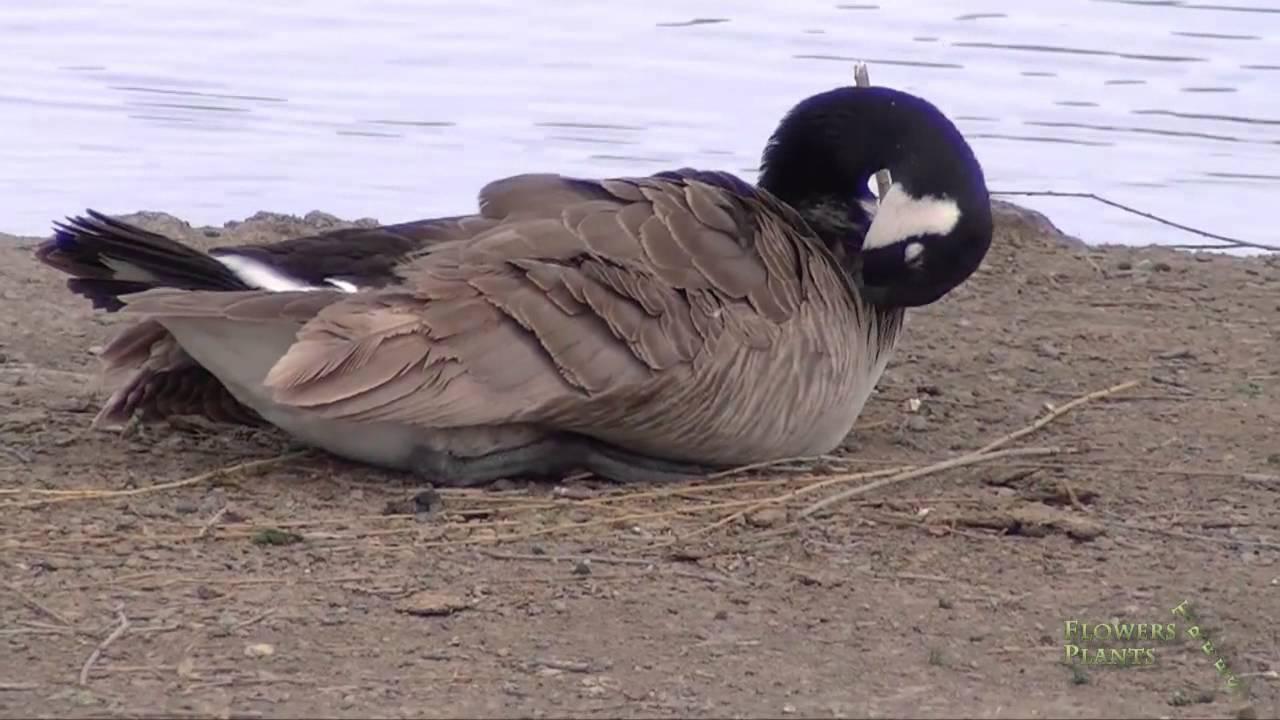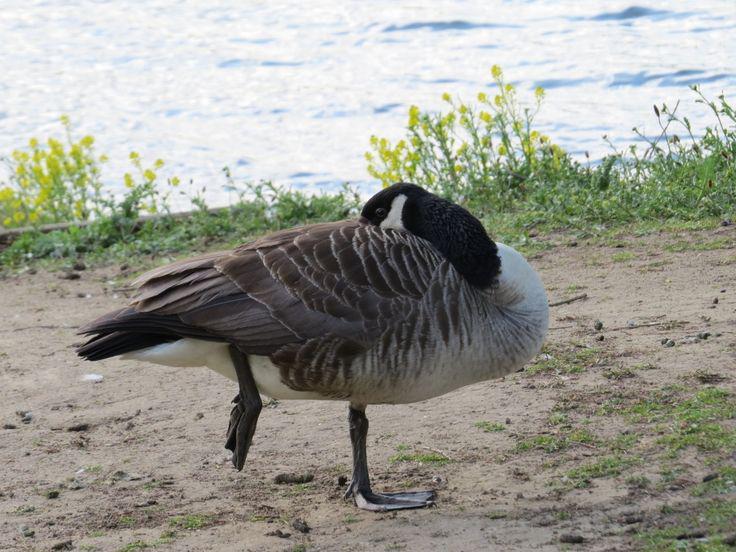The first image is the image on the left, the second image is the image on the right. Given the left and right images, does the statement "All the ducks are sleeping." hold true? Answer yes or no. Yes. The first image is the image on the left, the second image is the image on the right. Given the left and right images, does the statement "There are two birds in total." hold true? Answer yes or no. Yes. 